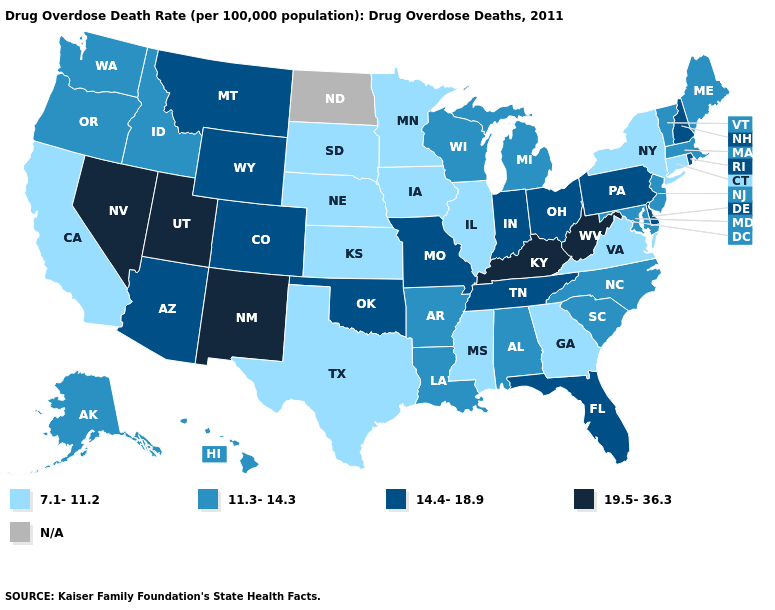Which states hav the highest value in the West?
Give a very brief answer. Nevada, New Mexico, Utah. Does Pennsylvania have the lowest value in the Northeast?
Answer briefly. No. Name the states that have a value in the range 7.1-11.2?
Short answer required. California, Connecticut, Georgia, Illinois, Iowa, Kansas, Minnesota, Mississippi, Nebraska, New York, South Dakota, Texas, Virginia. Name the states that have a value in the range 7.1-11.2?
Concise answer only. California, Connecticut, Georgia, Illinois, Iowa, Kansas, Minnesota, Mississippi, Nebraska, New York, South Dakota, Texas, Virginia. What is the highest value in states that border Georgia?
Be succinct. 14.4-18.9. Name the states that have a value in the range 7.1-11.2?
Be succinct. California, Connecticut, Georgia, Illinois, Iowa, Kansas, Minnesota, Mississippi, Nebraska, New York, South Dakota, Texas, Virginia. What is the value of Minnesota?
Short answer required. 7.1-11.2. Which states hav the highest value in the MidWest?
Short answer required. Indiana, Missouri, Ohio. What is the value of South Dakota?
Be succinct. 7.1-11.2. What is the value of Delaware?
Short answer required. 14.4-18.9. Name the states that have a value in the range N/A?
Concise answer only. North Dakota. Among the states that border New York , does New Jersey have the highest value?
Be succinct. No. Does Idaho have the highest value in the USA?
Quick response, please. No. 